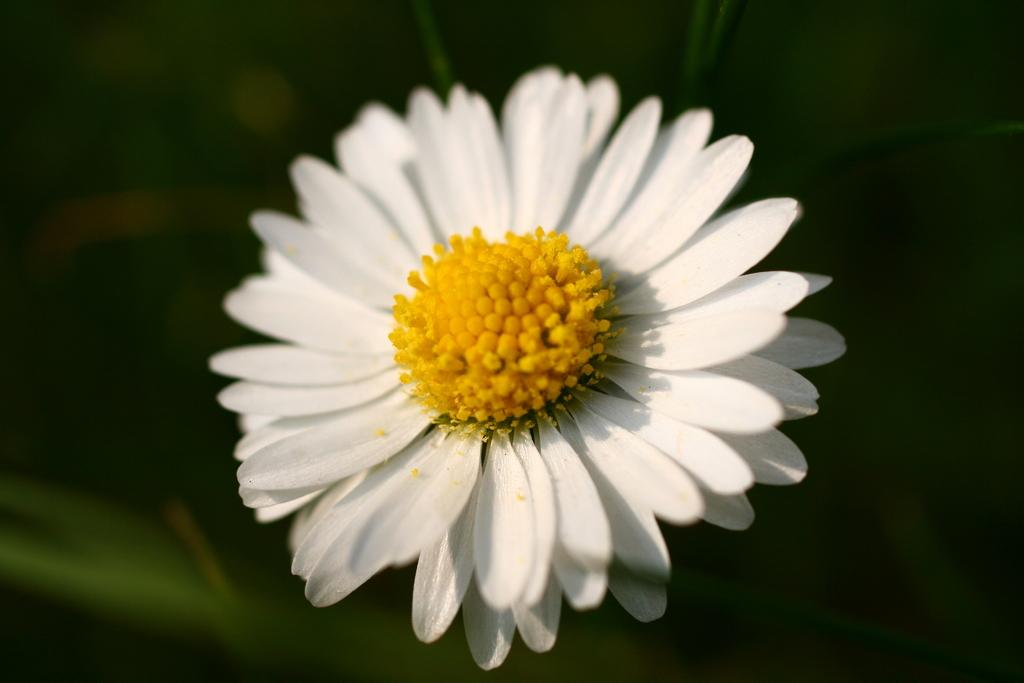What is the main subject of the image? There is a flower in the image. What type of noise can be heard coming from the cherry in the image? There is no cherry present in the image, and therefore no noise can be heard from it. 